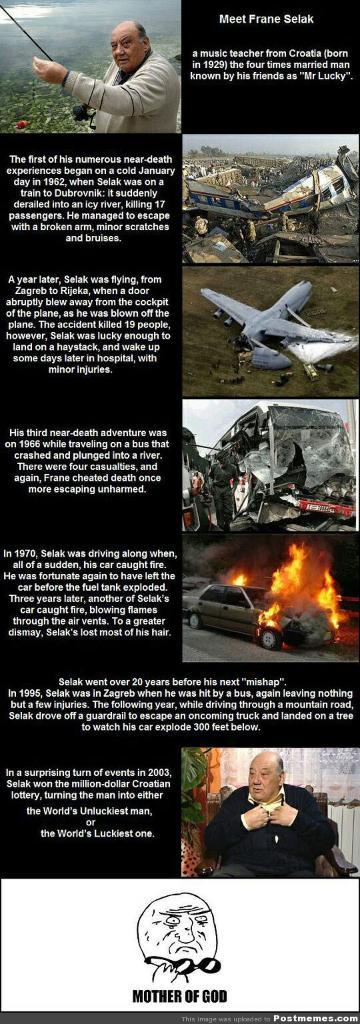Provide a one-sentence caption for the provided image. A listing of events in Frane Selak's life. 